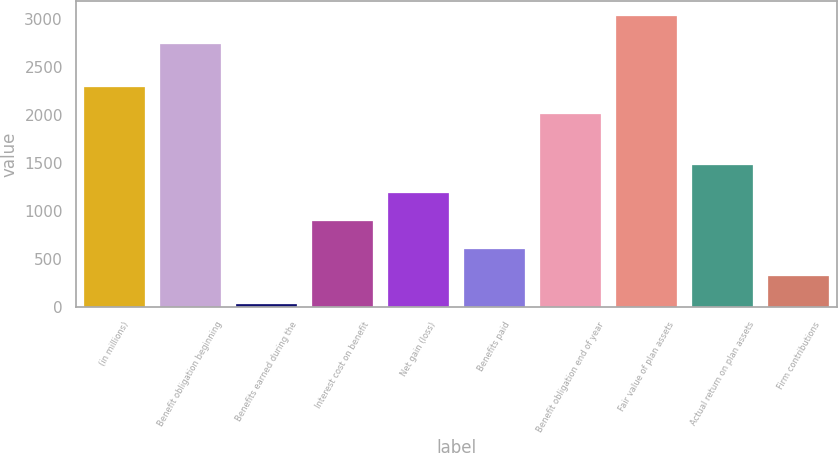Convert chart. <chart><loc_0><loc_0><loc_500><loc_500><bar_chart><fcel>(in millions)<fcel>Benefit obligation beginning<fcel>Benefits earned during the<fcel>Interest cost on benefit<fcel>Net gain (loss)<fcel>Benefits paid<fcel>Benefit obligation end of year<fcel>Fair value of plan assets<fcel>Actual return on plan assets<fcel>Firm contributions<nl><fcel>2297.4<fcel>2743<fcel>29<fcel>900.2<fcel>1190.6<fcel>609.8<fcel>2007<fcel>3033.4<fcel>1481<fcel>319.4<nl></chart> 